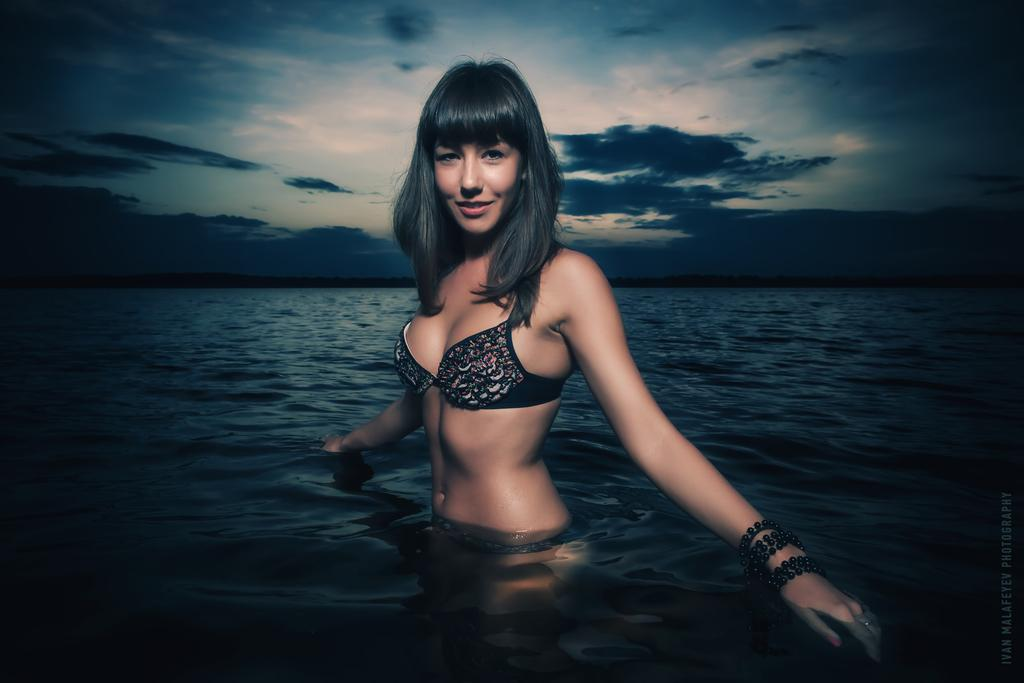What is the woman doing in the image? The woman is standing in the water. What can be seen in the background of the image? The sky is visible behind the woman. Is there any additional information about the image itself? Yes, there is a watermark on the image. What type of cannon is being fired in the image? There is no cannon present in the image; it features a woman standing in the water with a visible sky in the background. Can you describe the squirrel that is climbing the tree in the image? There is no squirrel or tree present in the image; it only shows a woman standing in the water with a visible sky in the background. 